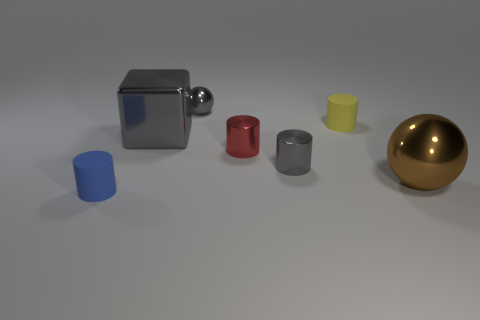Subtract all small gray metallic cylinders. How many cylinders are left? 3 Subtract all red cylinders. How many cylinders are left? 3 Add 1 green cubes. How many objects exist? 8 Subtract 1 cylinders. How many cylinders are left? 3 Subtract all cylinders. How many objects are left? 3 Subtract all purple cylinders. Subtract all green balls. How many cylinders are left? 4 Subtract all brown shiny blocks. Subtract all shiny things. How many objects are left? 2 Add 6 small matte cylinders. How many small matte cylinders are left? 8 Add 5 tiny cyan objects. How many tiny cyan objects exist? 5 Subtract 0 blue spheres. How many objects are left? 7 